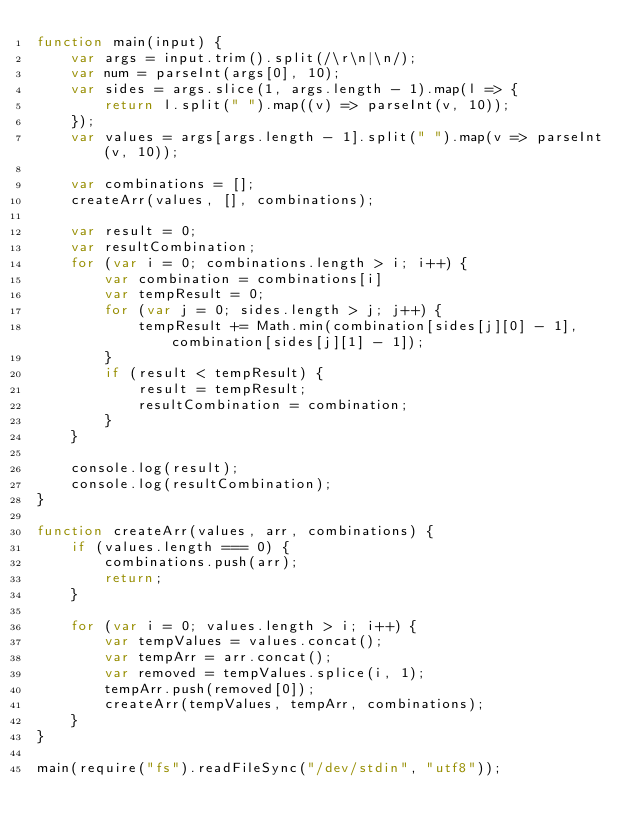Convert code to text. <code><loc_0><loc_0><loc_500><loc_500><_JavaScript_>function main(input) {
    var args = input.trim().split(/\r\n|\n/);
    var num = parseInt(args[0], 10);
    var sides = args.slice(1, args.length - 1).map(l => {
        return l.split(" ").map((v) => parseInt(v, 10));
    });
    var values = args[args.length - 1].split(" ").map(v => parseInt(v, 10));

    var combinations = [];
    createArr(values, [], combinations);

    var result = 0;
    var resultCombination;
    for (var i = 0; combinations.length > i; i++) {
        var combination = combinations[i]
        var tempResult = 0;
        for (var j = 0; sides.length > j; j++) {
            tempResult += Math.min(combination[sides[j][0] - 1], combination[sides[j][1] - 1]);
        }
        if (result < tempResult) {
            result = tempResult;
            resultCombination = combination;
        }
    }

    console.log(result);
    console.log(resultCombination);
}

function createArr(values, arr, combinations) {
    if (values.length === 0) {
        combinations.push(arr);
        return;
    }

    for (var i = 0; values.length > i; i++) {
        var tempValues = values.concat();
        var tempArr = arr.concat();
        var removed = tempValues.splice(i, 1);
        tempArr.push(removed[0]);
        createArr(tempValues, tempArr, combinations);
    }
}

main(require("fs").readFileSync("/dev/stdin", "utf8"));</code> 